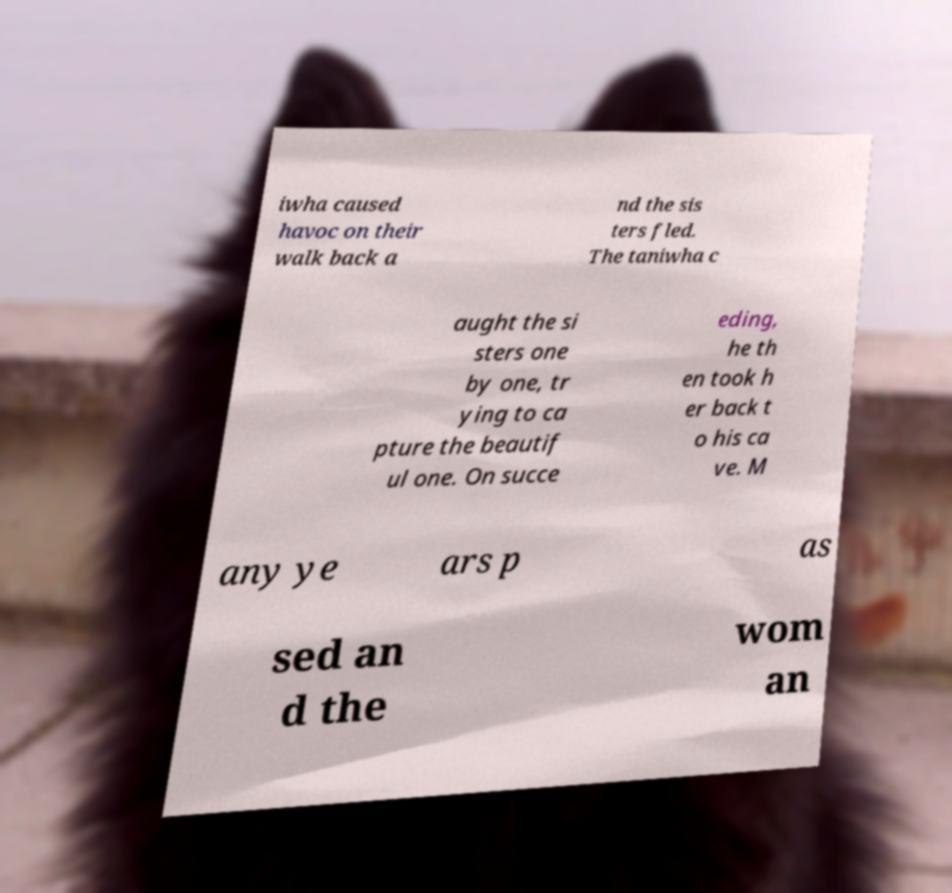Can you accurately transcribe the text from the provided image for me? iwha caused havoc on their walk back a nd the sis ters fled. The taniwha c aught the si sters one by one, tr ying to ca pture the beautif ul one. On succe eding, he th en took h er back t o his ca ve. M any ye ars p as sed an d the wom an 